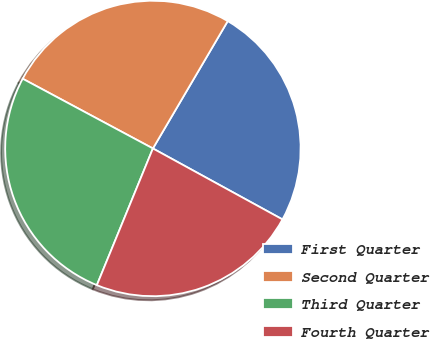<chart> <loc_0><loc_0><loc_500><loc_500><pie_chart><fcel>First Quarter<fcel>Second Quarter<fcel>Third Quarter<fcel>Fourth Quarter<nl><fcel>24.52%<fcel>25.63%<fcel>26.63%<fcel>23.22%<nl></chart> 